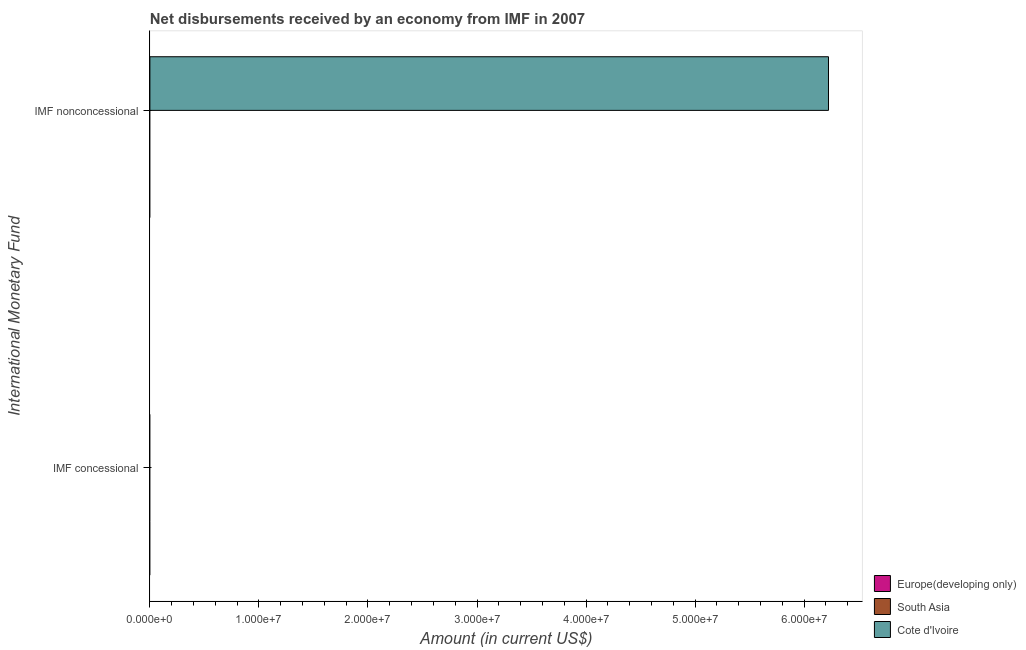Are the number of bars on each tick of the Y-axis equal?
Make the answer very short. No. How many bars are there on the 1st tick from the bottom?
Your response must be concise. 0. What is the label of the 2nd group of bars from the top?
Provide a succinct answer. IMF concessional. What is the net non concessional disbursements from imf in Cote d'Ivoire?
Your response must be concise. 6.22e+07. Across all countries, what is the maximum net non concessional disbursements from imf?
Your answer should be compact. 6.22e+07. In which country was the net non concessional disbursements from imf maximum?
Your answer should be compact. Cote d'Ivoire. What is the total net non concessional disbursements from imf in the graph?
Make the answer very short. 6.22e+07. What is the difference between the net non concessional disbursements from imf in Cote d'Ivoire and the net concessional disbursements from imf in South Asia?
Make the answer very short. 6.22e+07. What is the average net concessional disbursements from imf per country?
Your answer should be compact. 0. In how many countries, is the net concessional disbursements from imf greater than the average net concessional disbursements from imf taken over all countries?
Your answer should be compact. 0. How many countries are there in the graph?
Ensure brevity in your answer.  3. What is the difference between two consecutive major ticks on the X-axis?
Offer a terse response. 1.00e+07. Are the values on the major ticks of X-axis written in scientific E-notation?
Offer a terse response. Yes. Does the graph contain any zero values?
Keep it short and to the point. Yes. Does the graph contain grids?
Your response must be concise. No. Where does the legend appear in the graph?
Your answer should be compact. Bottom right. How many legend labels are there?
Provide a short and direct response. 3. What is the title of the graph?
Ensure brevity in your answer.  Net disbursements received by an economy from IMF in 2007. What is the label or title of the X-axis?
Keep it short and to the point. Amount (in current US$). What is the label or title of the Y-axis?
Your answer should be very brief. International Monetary Fund. What is the Amount (in current US$) in Cote d'Ivoire in IMF concessional?
Make the answer very short. 0. What is the Amount (in current US$) in Cote d'Ivoire in IMF nonconcessional?
Keep it short and to the point. 6.22e+07. Across all International Monetary Fund, what is the maximum Amount (in current US$) of Cote d'Ivoire?
Keep it short and to the point. 6.22e+07. What is the total Amount (in current US$) of Europe(developing only) in the graph?
Your response must be concise. 0. What is the total Amount (in current US$) in South Asia in the graph?
Keep it short and to the point. 0. What is the total Amount (in current US$) in Cote d'Ivoire in the graph?
Your answer should be compact. 6.22e+07. What is the average Amount (in current US$) of South Asia per International Monetary Fund?
Keep it short and to the point. 0. What is the average Amount (in current US$) in Cote d'Ivoire per International Monetary Fund?
Offer a very short reply. 3.11e+07. What is the difference between the highest and the lowest Amount (in current US$) of Cote d'Ivoire?
Your answer should be very brief. 6.22e+07. 